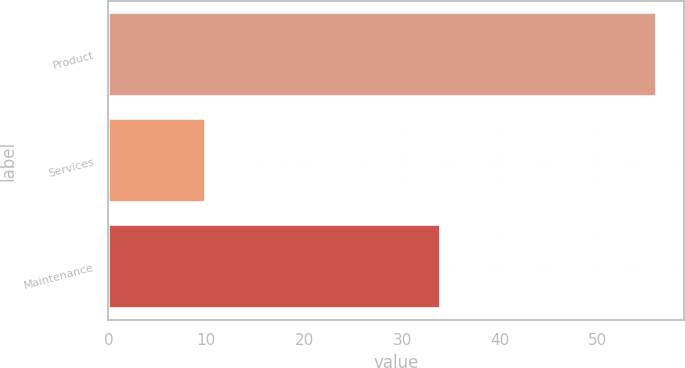Convert chart. <chart><loc_0><loc_0><loc_500><loc_500><bar_chart><fcel>Product<fcel>Services<fcel>Maintenance<nl><fcel>56<fcel>10<fcel>34<nl></chart> 